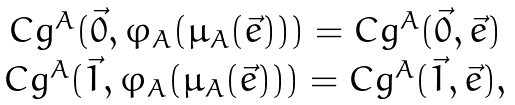Convert formula to latex. <formula><loc_0><loc_0><loc_500><loc_500>\begin{array} { c c c } C g ^ { A } ( \vec { 0 } , \varphi _ { A } ( \mu _ { A } ( \vec { e } ) ) ) = C g ^ { A } ( \vec { 0 } , \vec { e } ) \\ C g ^ { A } ( \vec { 1 } , \varphi _ { A } ( \mu _ { A } ( \vec { e } ) ) ) = C g ^ { A } ( \vec { 1 } , \vec { e } ) , \end{array}</formula> 